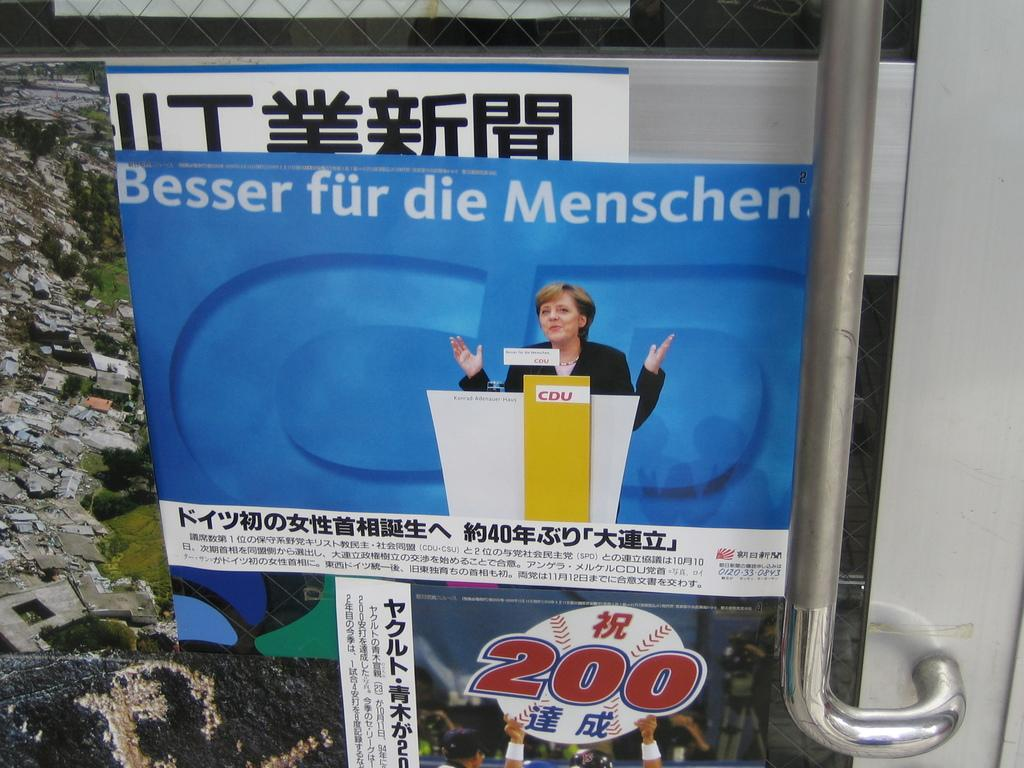<image>
Share a concise interpretation of the image provided. A poster that says Besser fur die Menschen. 